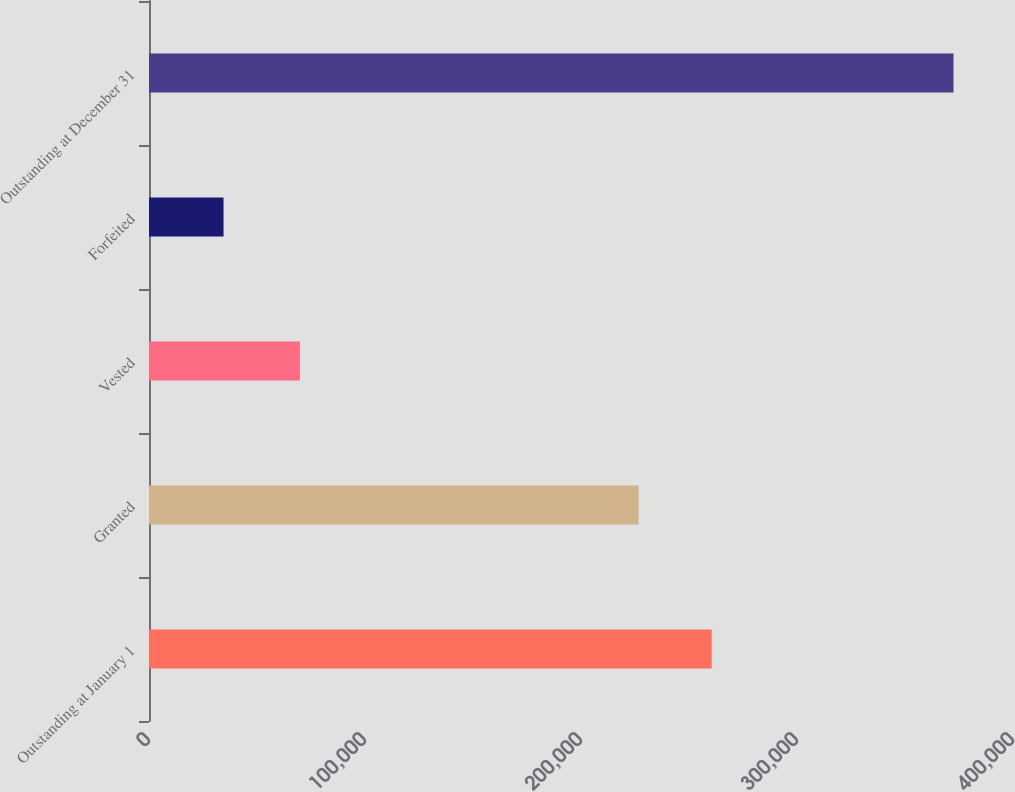Convert chart to OTSL. <chart><loc_0><loc_0><loc_500><loc_500><bar_chart><fcel>Outstanding at January 1<fcel>Granted<fcel>Vested<fcel>Forfeited<fcel>Outstanding at December 31<nl><fcel>260495<fcel>226700<fcel>69872<fcel>34500<fcel>372453<nl></chart> 